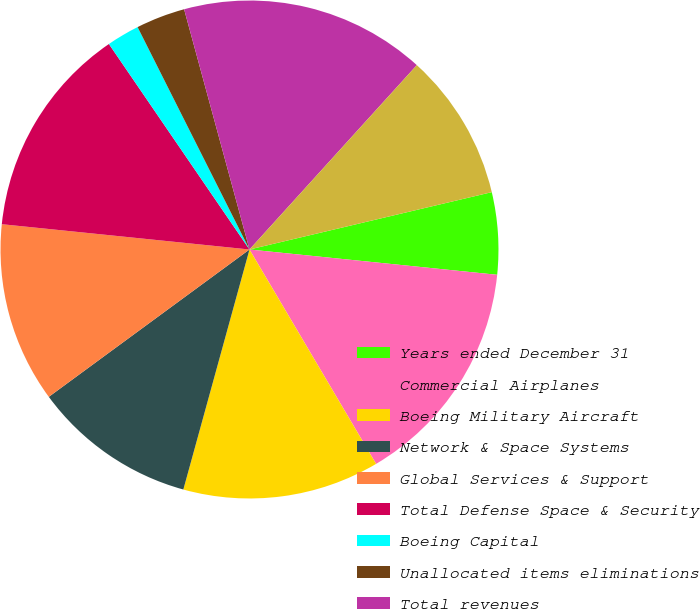Convert chart. <chart><loc_0><loc_0><loc_500><loc_500><pie_chart><fcel>Years ended December 31<fcel>Commercial Airplanes<fcel>Boeing Military Aircraft<fcel>Network & Space Systems<fcel>Global Services & Support<fcel>Total Defense Space & Security<fcel>Boeing Capital<fcel>Unallocated items eliminations<fcel>Total revenues<fcel>Earnings from operations<nl><fcel>5.32%<fcel>14.89%<fcel>12.77%<fcel>10.64%<fcel>11.7%<fcel>13.83%<fcel>2.13%<fcel>3.19%<fcel>15.96%<fcel>9.57%<nl></chart> 